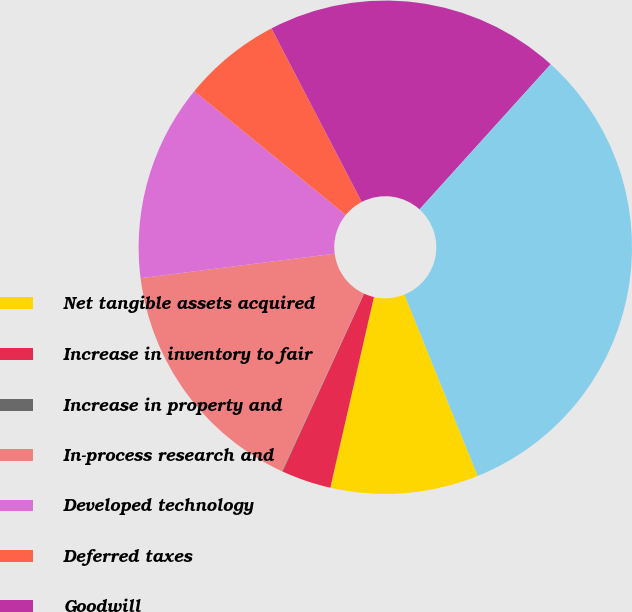Convert chart. <chart><loc_0><loc_0><loc_500><loc_500><pie_chart><fcel>Net tangible assets acquired<fcel>Increase in inventory to fair<fcel>Increase in property and<fcel>In-process research and<fcel>Developed technology<fcel>Deferred taxes<fcel>Goodwill<fcel>Estimated Purchase Price<nl><fcel>9.69%<fcel>3.26%<fcel>0.04%<fcel>16.12%<fcel>12.9%<fcel>6.47%<fcel>19.33%<fcel>32.19%<nl></chart> 